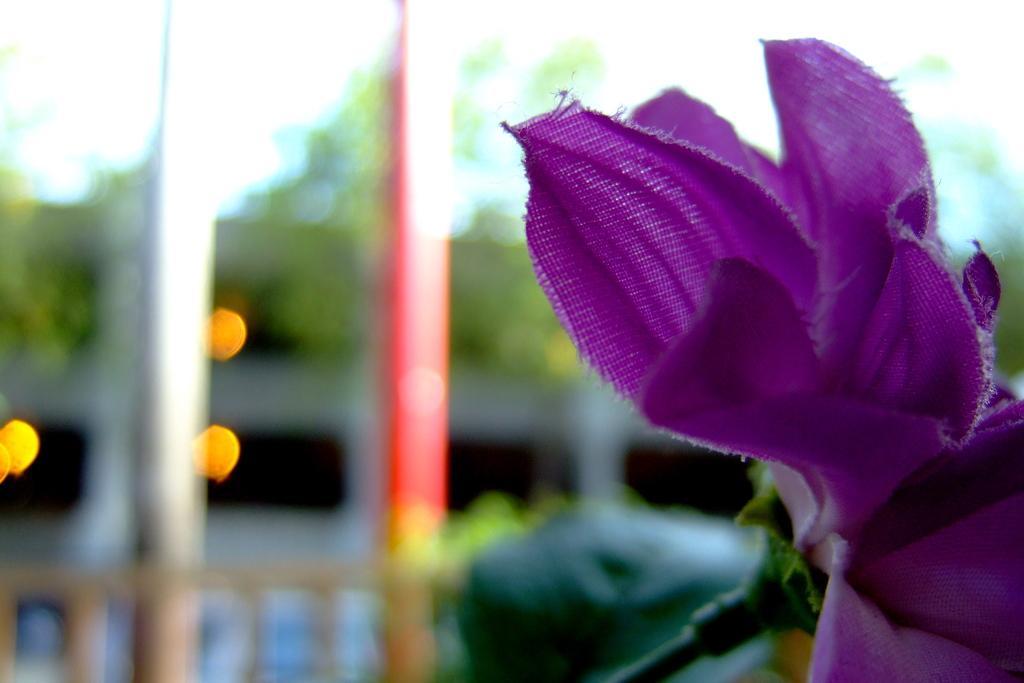Describe this image in one or two sentences. On the right side of the image we can see the purple color artificial flower. The background of the image is blurred. 